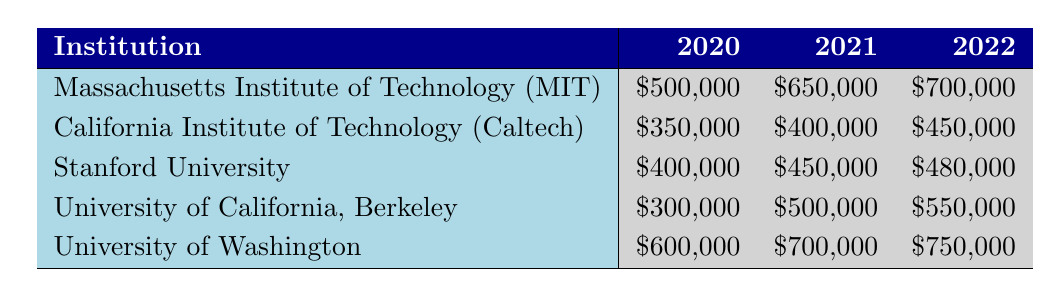What was the total funding for the University of Washington from 2020 to 2022? The funding amounts for the University of Washington are $600,000 (2020), $700,000 (2021), and $750,000 (2022). Adding these give: 600,000 + 700,000 + 750,000 = 2,050,000.
Answer: 2,050,000 Which institution received the least funding in 2020? In 2020, looking at the funding amounts: MIT received $500,000, Caltech $350,000, Stanford $400,000, Berkeley $300,000, and UW $600,000. The least amount is from California Institute of Technology at $350,000.
Answer: California Institute of Technology Did any institution receive the same amount of funding in consecutive years? The funding amounts are as follows: MIT received $500,000 in 2020 and $650,000 in 2021, which is a change. Caltech received $350,000, $400,000, and so on. Checking through, no institution has the same amount in any two consecutive years.
Answer: No What is the average funding amount for Stanford University across the three years? The funding amounts for Stanford are $400,000 (2020), $450,000 (2021), and $480,000 (2022). The total is 400,000 + 450,000 + 480,000 = 1,330,000. There are three years, thus the average is 1,330,000 / 3 = 443,333.33, which rounds to approximately $443,333.
Answer: 443,333 Which institution had the highest increase in funding from 2020 to 2021? First, determine the increase for each institution: MIT increased by $150,000, Caltech by $50,000, Stanford by $50,000, Berkeley by $200,000, and UW by $100,000. The highest increase is Berkeley's increase of $200,000.
Answer: University of California, Berkeley 